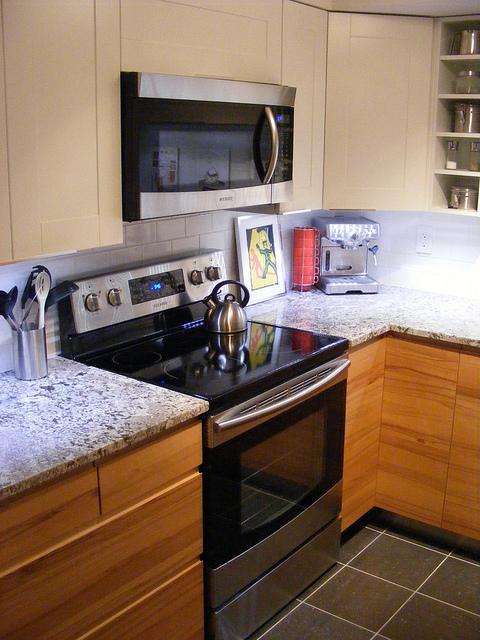Where is the tea kettle?
Keep it brief. Stove. What type of countertops are there?
Keep it brief. Granite. Is the stove in use?
Short answer required. No. What appliance is the black object?
Answer briefly. Stove. 